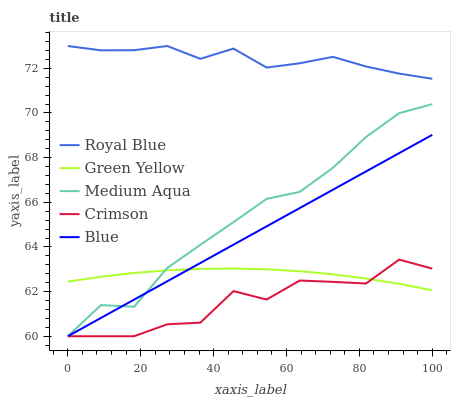Does Crimson have the minimum area under the curve?
Answer yes or no. Yes. Does Royal Blue have the maximum area under the curve?
Answer yes or no. Yes. Does Green Yellow have the minimum area under the curve?
Answer yes or no. No. Does Green Yellow have the maximum area under the curve?
Answer yes or no. No. Is Blue the smoothest?
Answer yes or no. Yes. Is Crimson the roughest?
Answer yes or no. Yes. Is Royal Blue the smoothest?
Answer yes or no. No. Is Royal Blue the roughest?
Answer yes or no. No. Does Green Yellow have the lowest value?
Answer yes or no. No. Does Royal Blue have the highest value?
Answer yes or no. Yes. Does Green Yellow have the highest value?
Answer yes or no. No. Is Blue less than Royal Blue?
Answer yes or no. Yes. Is Royal Blue greater than Blue?
Answer yes or no. Yes. Does Medium Aqua intersect Blue?
Answer yes or no. Yes. Is Medium Aqua less than Blue?
Answer yes or no. No. Is Medium Aqua greater than Blue?
Answer yes or no. No. Does Blue intersect Royal Blue?
Answer yes or no. No. 